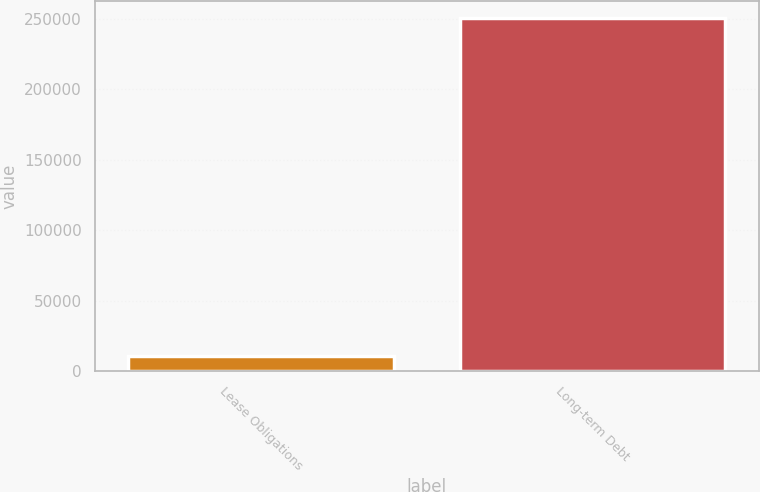Convert chart. <chart><loc_0><loc_0><loc_500><loc_500><bar_chart><fcel>Lease Obligations<fcel>Long-term Debt<nl><fcel>11108<fcel>250187<nl></chart> 